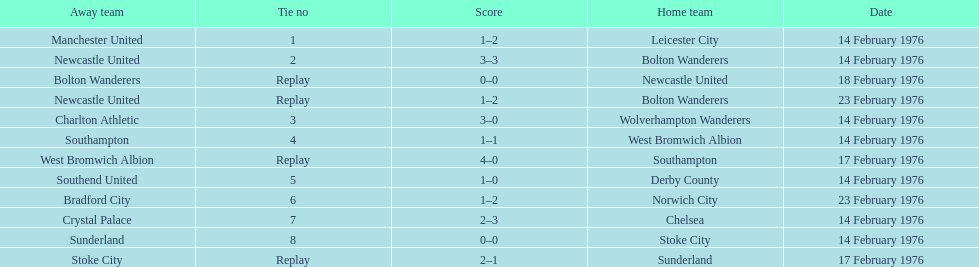What is the difference between southampton's score and sunderland's score? 2 goals. 